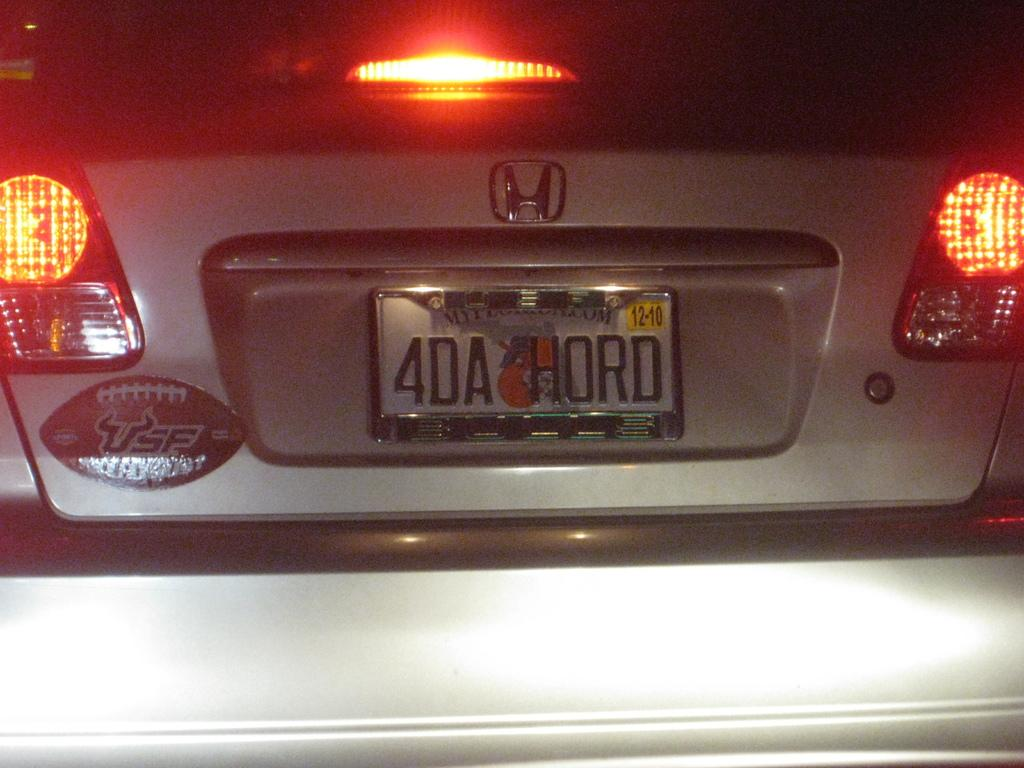Provide a one-sentence caption for the provided image. A silver Honda Civic with a USF football sticker and a license plate that reads 4DA HORD. 